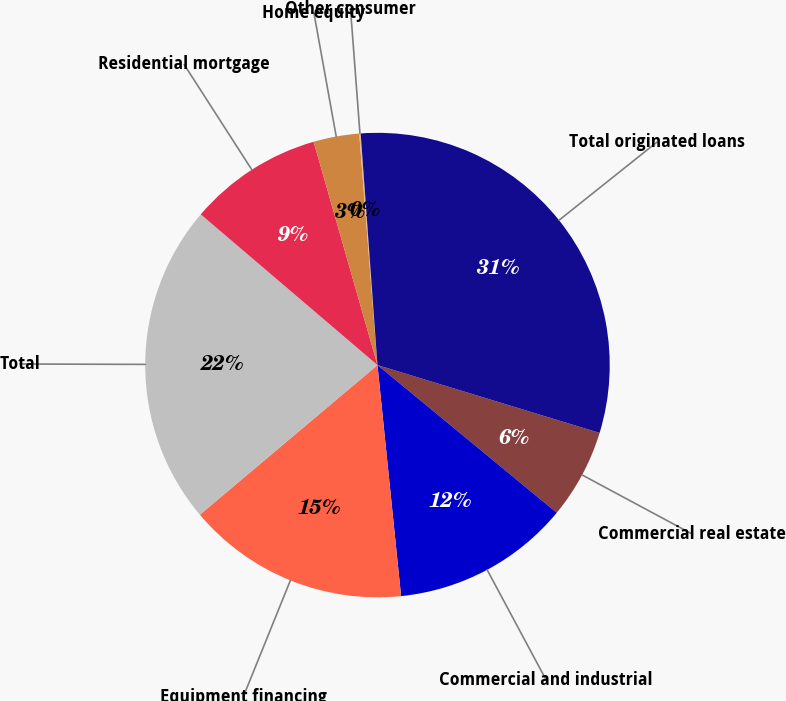Convert chart to OTSL. <chart><loc_0><loc_0><loc_500><loc_500><pie_chart><fcel>Commercial real estate<fcel>Commercial and industrial<fcel>Equipment financing<fcel>Total<fcel>Residential mortgage<fcel>Home equity<fcel>Other consumer<fcel>Total originated loans<nl><fcel>6.25%<fcel>12.41%<fcel>15.48%<fcel>22.38%<fcel>9.33%<fcel>3.18%<fcel>0.1%<fcel>30.87%<nl></chart> 